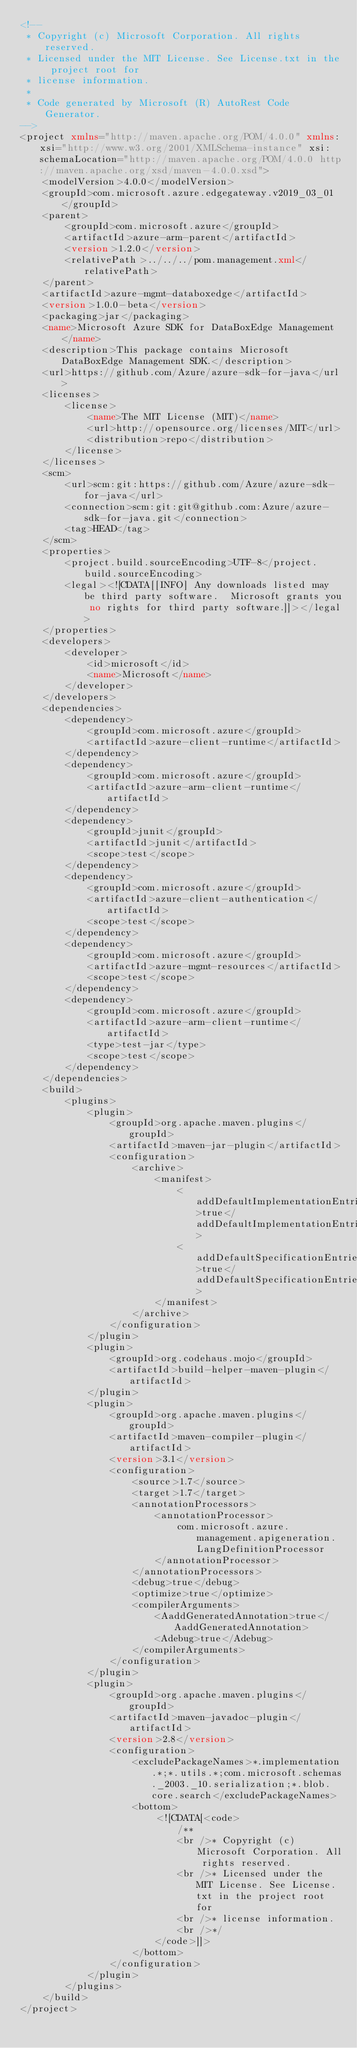<code> <loc_0><loc_0><loc_500><loc_500><_XML_><!--
 * Copyright (c) Microsoft Corporation. All rights reserved.
 * Licensed under the MIT License. See License.txt in the project root for
 * license information.
 *
 * Code generated by Microsoft (R) AutoRest Code Generator.
-->
<project xmlns="http://maven.apache.org/POM/4.0.0" xmlns:xsi="http://www.w3.org/2001/XMLSchema-instance" xsi:schemaLocation="http://maven.apache.org/POM/4.0.0 http://maven.apache.org/xsd/maven-4.0.0.xsd">
    <modelVersion>4.0.0</modelVersion>
    <groupId>com.microsoft.azure.edgegateway.v2019_03_01</groupId>
    <parent>
        <groupId>com.microsoft.azure</groupId>
        <artifactId>azure-arm-parent</artifactId>
        <version>1.2.0</version>
        <relativePath>../../../pom.management.xml</relativePath>
    </parent>
    <artifactId>azure-mgmt-databoxedge</artifactId>
    <version>1.0.0-beta</version>
    <packaging>jar</packaging>
    <name>Microsoft Azure SDK for DataBoxEdge Management</name>
    <description>This package contains Microsoft DataBoxEdge Management SDK.</description>
    <url>https://github.com/Azure/azure-sdk-for-java</url>
    <licenses>
        <license>
            <name>The MIT License (MIT)</name>
            <url>http://opensource.org/licenses/MIT</url>
            <distribution>repo</distribution>
        </license>
    </licenses>
    <scm>
        <url>scm:git:https://github.com/Azure/azure-sdk-for-java</url>
        <connection>scm:git:git@github.com:Azure/azure-sdk-for-java.git</connection>
        <tag>HEAD</tag>
    </scm>
    <properties>
        <project.build.sourceEncoding>UTF-8</project.build.sourceEncoding>
        <legal><![CDATA[[INFO] Any downloads listed may be third party software.  Microsoft grants you no rights for third party software.]]></legal>
    </properties>
    <developers>
        <developer>
            <id>microsoft</id>
            <name>Microsoft</name>
        </developer>
    </developers>
    <dependencies>
        <dependency>
            <groupId>com.microsoft.azure</groupId>
            <artifactId>azure-client-runtime</artifactId>
        </dependency>
        <dependency>
            <groupId>com.microsoft.azure</groupId>
            <artifactId>azure-arm-client-runtime</artifactId>
        </dependency>
        <dependency>
            <groupId>junit</groupId>
            <artifactId>junit</artifactId>
            <scope>test</scope>
        </dependency>
        <dependency>
            <groupId>com.microsoft.azure</groupId>
            <artifactId>azure-client-authentication</artifactId>
            <scope>test</scope>
        </dependency>
        <dependency>
            <groupId>com.microsoft.azure</groupId>
            <artifactId>azure-mgmt-resources</artifactId>
            <scope>test</scope>
        </dependency>
        <dependency>
            <groupId>com.microsoft.azure</groupId>
            <artifactId>azure-arm-client-runtime</artifactId>
            <type>test-jar</type>
            <scope>test</scope>
        </dependency>
    </dependencies>
    <build>
        <plugins>
            <plugin>
                <groupId>org.apache.maven.plugins</groupId>
                <artifactId>maven-jar-plugin</artifactId>
                <configuration>
                    <archive>
                        <manifest>
                            <addDefaultImplementationEntries>true</addDefaultImplementationEntries>
                            <addDefaultSpecificationEntries>true</addDefaultSpecificationEntries>
                        </manifest>
                    </archive>
                </configuration>
            </plugin>
            <plugin>
                <groupId>org.codehaus.mojo</groupId>
                <artifactId>build-helper-maven-plugin</artifactId>
            </plugin>
            <plugin>
                <groupId>org.apache.maven.plugins</groupId>
                <artifactId>maven-compiler-plugin</artifactId>
                <version>3.1</version>
                <configuration>
                    <source>1.7</source>
                    <target>1.7</target>
                    <annotationProcessors>
                        <annotationProcessor>
                            com.microsoft.azure.management.apigeneration.LangDefinitionProcessor
                        </annotationProcessor>
                    </annotationProcessors>
                    <debug>true</debug>
                    <optimize>true</optimize>
                    <compilerArguments>
                        <AaddGeneratedAnnotation>true</AaddGeneratedAnnotation>
                        <Adebug>true</Adebug>
                    </compilerArguments>
                </configuration>
            </plugin>
            <plugin>
                <groupId>org.apache.maven.plugins</groupId>
                <artifactId>maven-javadoc-plugin</artifactId>
                <version>2.8</version>
                <configuration>
                    <excludePackageNames>*.implementation.*;*.utils.*;com.microsoft.schemas._2003._10.serialization;*.blob.core.search</excludePackageNames>
                    <bottom>
                        <![CDATA[<code>
                            /**
                            <br />* Copyright (c) Microsoft Corporation. All rights reserved.
                            <br />* Licensed under the MIT License. See License.txt in the project root for
                            <br />* license information.
                            <br />*/
                        </code>]]>
                    </bottom>
                </configuration>
            </plugin>
        </plugins>
    </build>
</project>
</code> 